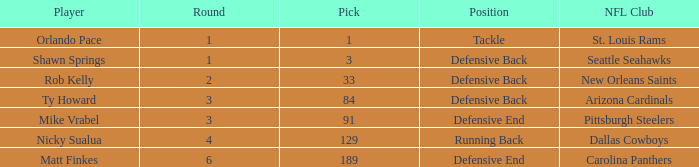What lowest round has orlando pace as the player? 1.0. 